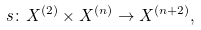<formula> <loc_0><loc_0><loc_500><loc_500>s \colon X ^ { ( 2 ) } \times X ^ { ( n ) } \rightarrow X ^ { ( n + 2 ) } ,</formula> 